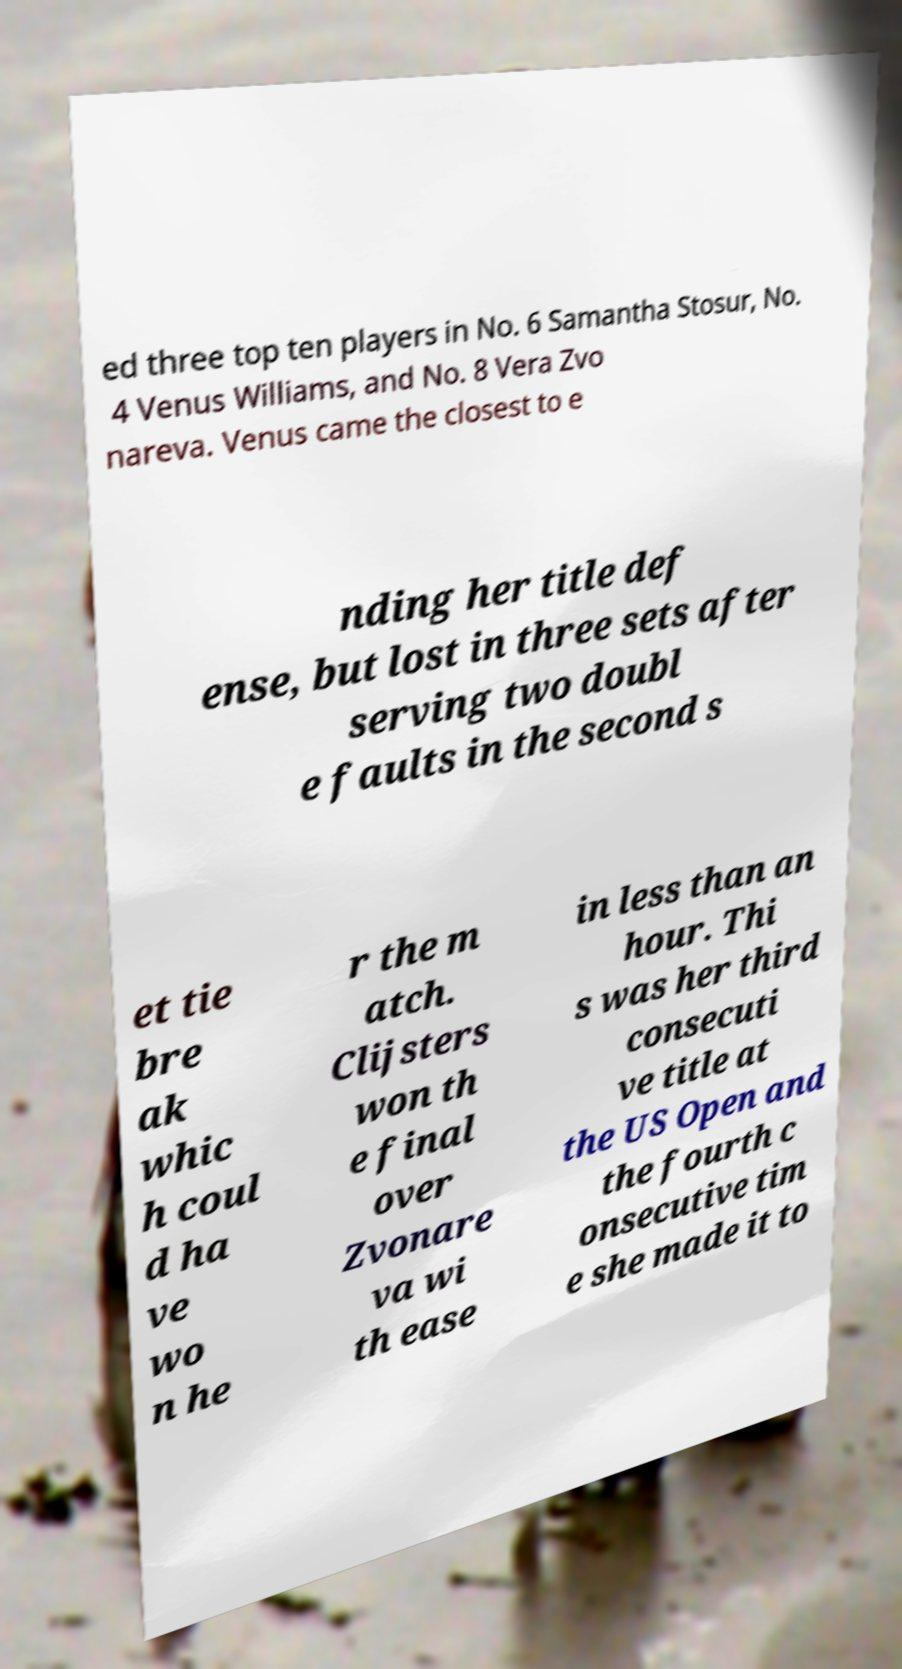Can you read and provide the text displayed in the image?This photo seems to have some interesting text. Can you extract and type it out for me? ed three top ten players in No. 6 Samantha Stosur, No. 4 Venus Williams, and No. 8 Vera Zvo nareva. Venus came the closest to e nding her title def ense, but lost in three sets after serving two doubl e faults in the second s et tie bre ak whic h coul d ha ve wo n he r the m atch. Clijsters won th e final over Zvonare va wi th ease in less than an hour. Thi s was her third consecuti ve title at the US Open and the fourth c onsecutive tim e she made it to 